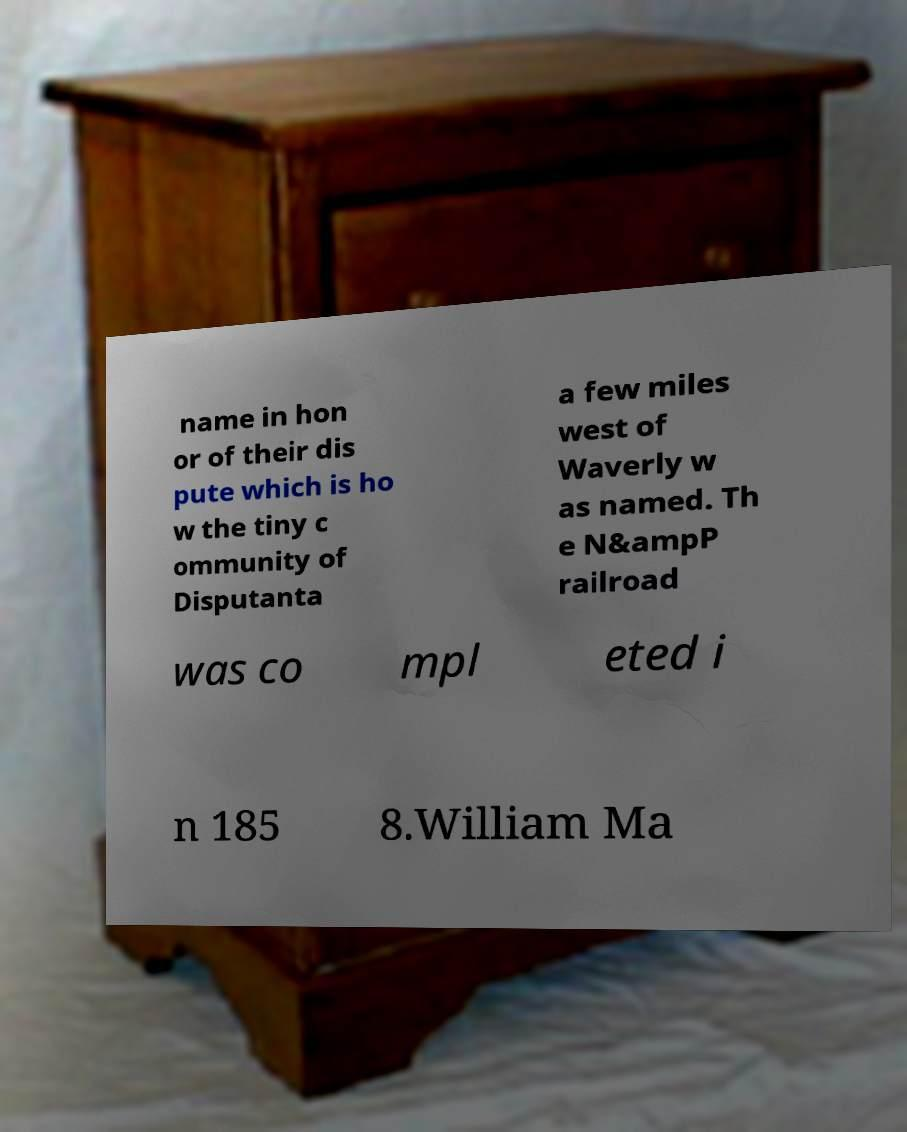For documentation purposes, I need the text within this image transcribed. Could you provide that? name in hon or of their dis pute which is ho w the tiny c ommunity of Disputanta a few miles west of Waverly w as named. Th e N&ampP railroad was co mpl eted i n 185 8.William Ma 